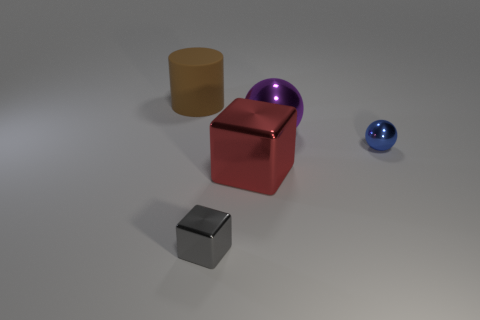There is a tiny metallic thing to the right of the big red shiny object right of the tiny thing that is left of the tiny sphere; what shape is it?
Provide a succinct answer. Sphere. Is the number of big purple spheres that are behind the large brown rubber thing greater than the number of large blocks?
Your answer should be very brief. No. Does the small metallic object that is to the right of the tiny gray object have the same shape as the small gray object?
Ensure brevity in your answer.  No. There is a big thing to the right of the red metal block; what material is it?
Offer a terse response. Metal. How many big purple metallic objects have the same shape as the blue object?
Make the answer very short. 1. What material is the large object on the left side of the small metallic object in front of the blue thing?
Provide a short and direct response. Rubber. Are there any red blocks made of the same material as the purple thing?
Your answer should be compact. Yes. The tiny blue metallic object has what shape?
Your answer should be very brief. Sphere. How many big matte cylinders are there?
Provide a succinct answer. 1. The big metal thing that is left of the shiny sphere left of the blue ball is what color?
Offer a very short reply. Red. 